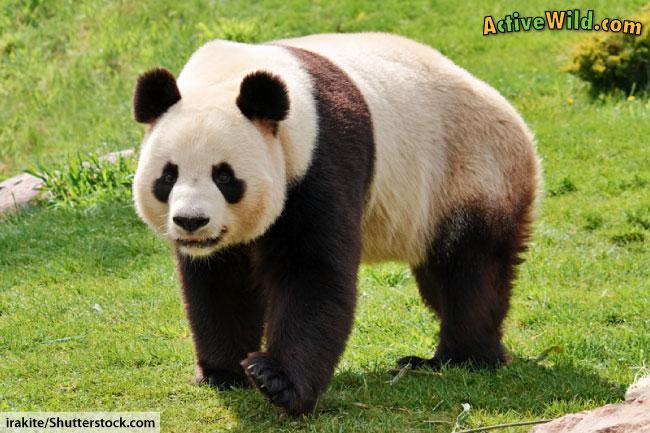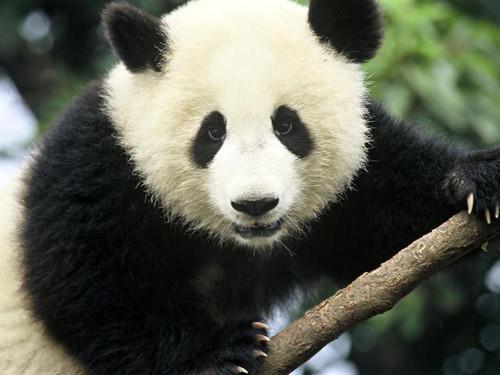The first image is the image on the left, the second image is the image on the right. Given the left and right images, does the statement "One panda image features an expanse of green lawn in the background." hold true? Answer yes or no. Yes. 